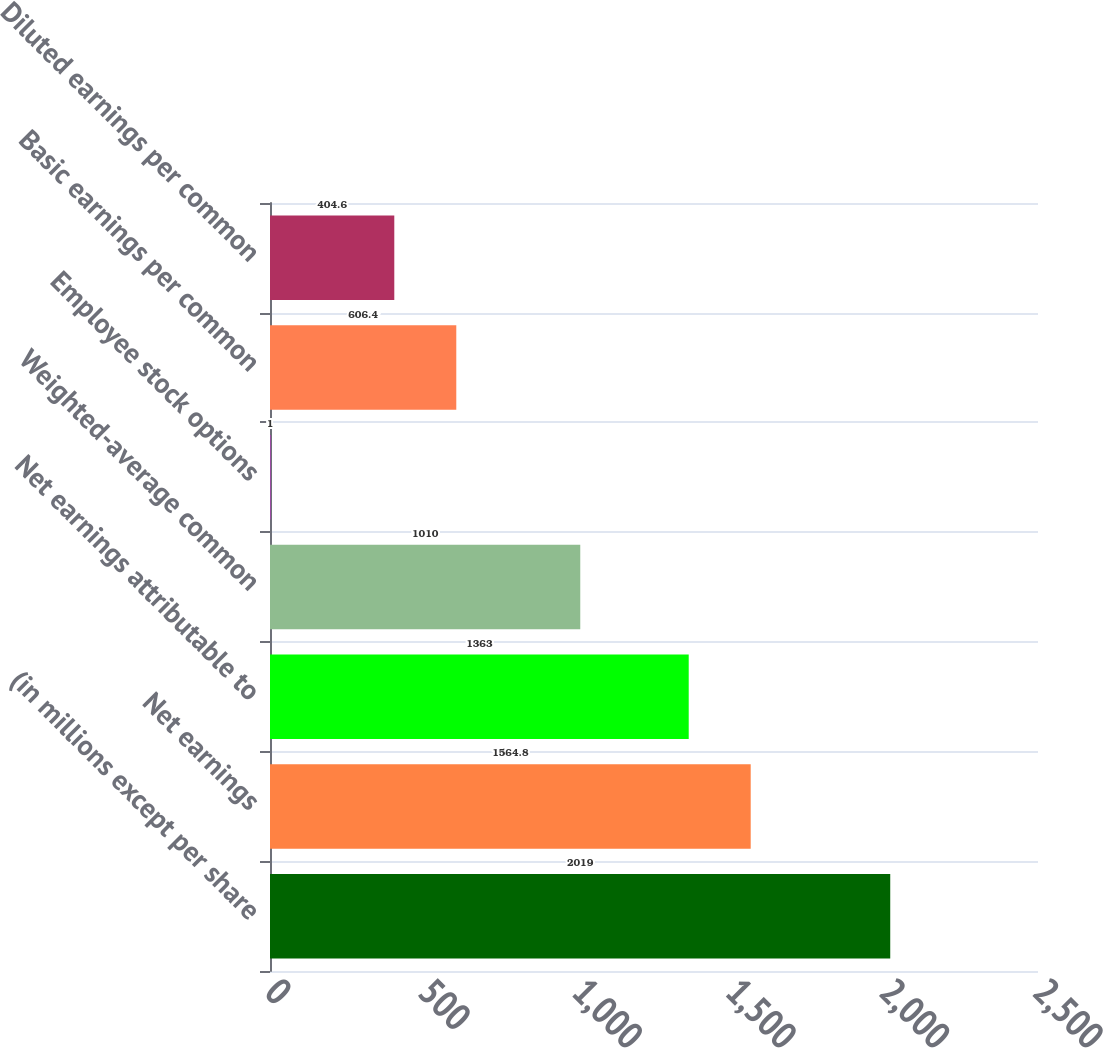Convert chart to OTSL. <chart><loc_0><loc_0><loc_500><loc_500><bar_chart><fcel>(in millions except per share<fcel>Net earnings<fcel>Net earnings attributable to<fcel>Weighted-average common<fcel>Employee stock options<fcel>Basic earnings per common<fcel>Diluted earnings per common<nl><fcel>2019<fcel>1564.8<fcel>1363<fcel>1010<fcel>1<fcel>606.4<fcel>404.6<nl></chart> 